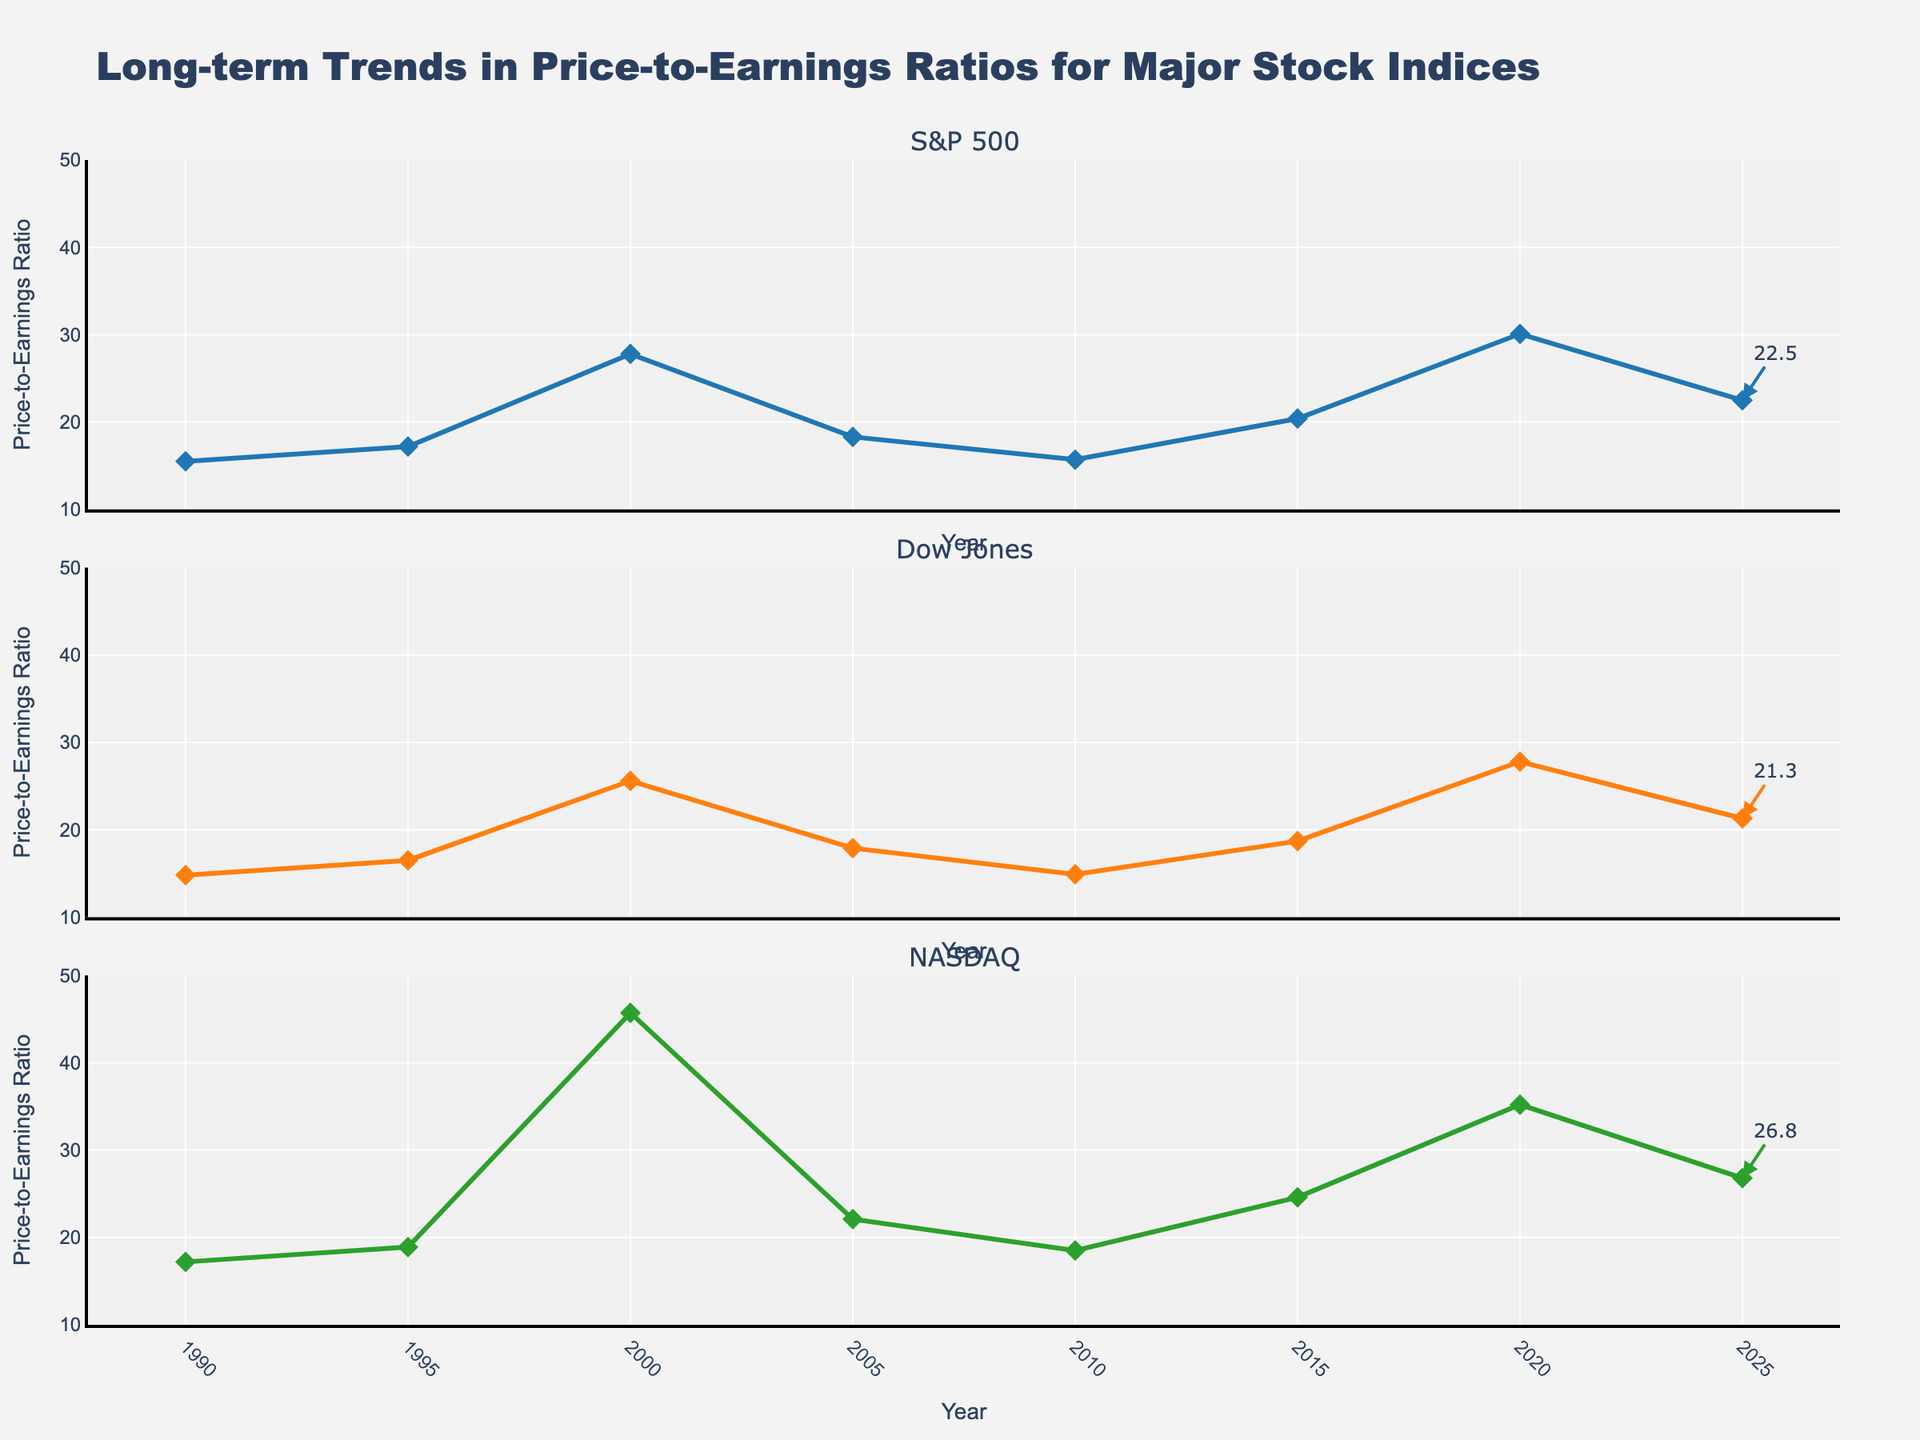What is the title of the figure? The title is displayed at the top of the figure. It reads, "Long-term Trends in Price-to-Earnings Ratios for Major Stock Indices".
Answer: Long-term Trends in Price-to-Earnings Ratios for Major Stock Indices Which index had the highest price-to-earnings ratio in the year 2000? Look at the values for the year 2000 in each subplot. The NASDAQ has the highest value at 45.7.
Answer: NASDAQ What is the range of the price-to-earnings ratio on the y-axis? The y-axis is labeled from 10 to 50, which is the range.
Answer: 10 to 50 How many years of data are presented in the figure? Count the number of distinct years listed on the x-axis. There are 8 years from 1990 to 2025.
Answer: 8 Which index experienced the greatest increase in price-to-earnings ratio between 2010 and 2020? Calculate the difference for each index: 
S&P 500 (30.1 - 15.7 = 14.4),
Dow Jones (27.8 - 14.9 = 12.9),
NASDAQ (35.2 - 18.5 = 16.7).
NASDAQ had the greatest increase.
Answer: NASDAQ What was the price-to-earnings ratio for the S&P 500 in 1995? Refer to the value for the S&P 500 in the year 1995 on the first subplot. The value is 17.2.
Answer: 17.2 Comparing the years 1990 and 2025, which index had the smallest relative increase in the price-to-earnings ratio? Calculate the relative increase for each index:
S&P 500 ((22.5 - 15.5) / 15.5) = 0.45,
Dow Jones ((21.3 - 14.8) / 14.8) = 0.44,
NASDAQ ((26.8 - 17.2) / 17.2) = 0.56.
Dow Jones had the smallest increase.
Answer: Dow Jones Which index showed the most consistent trend over the years? Visual inspection suggests that the Dow Jones presents the most consistent, gradual trend. There are fewer spikes and more gradual changes compared to S&P 500 and NASDAQ.
Answer: Dow Jones What is the annotation value for the NASDAQ in 2025? Look at the annotation on the NASDAQ subplot for the year 2025; the annotated value is 26.8.
Answer: 26.8 In which year did the S&P 500 and Dow Jones have almost similar price-to-earnings ratios? Check the values over the years where the difference between S&P 500 and Dow Jones is minimal:
In 1990: S&P 500 = 15.5, Dow Jones = 14.8; 
In 2005: S&P 500 = 18.3, Dow Jones = 17.9.
The smallest difference is in 2005.
Answer: 2005 